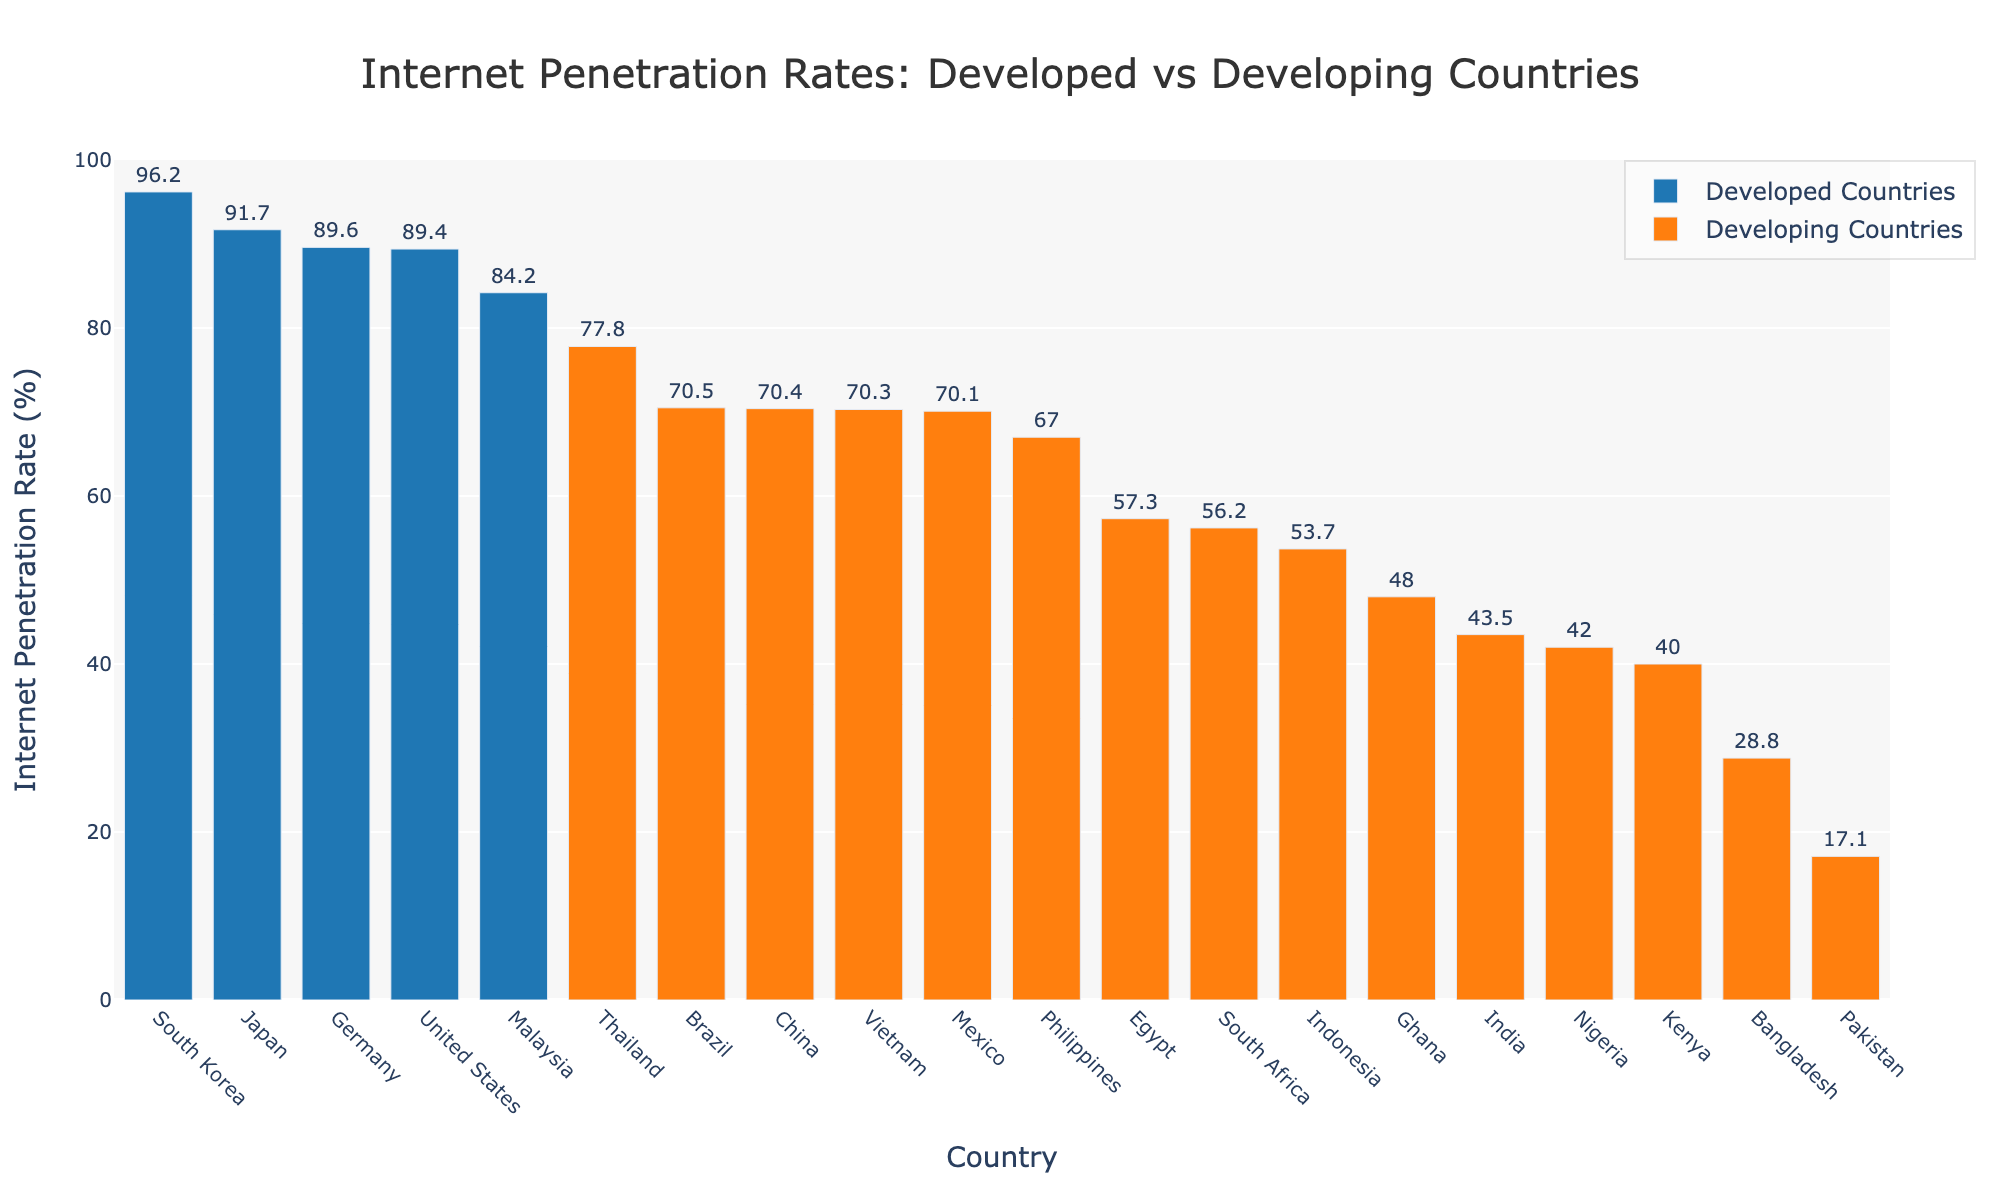Which country has the highest Internet penetration rate among developing countries? To find the country with the highest Internet penetration rate among developing countries, look for the tallest orange bar in the figure, representing developing countries. Compare the heights of the bars to identify the highest one.
Answer: South Korea What is the Internet penetration rate difference between Japan and India? Identify the bars representing Japan and India, then note their Internet penetration rates. Subtract India's rate (43.5%) from Japan's rate (91.7%) to get the difference.
Answer: 48.2% Which group, developed or developing countries, has the country with the lowest Internet penetration rate? Look for the shortest bar in the entire figure. Since the shortest one will indicate the lowest Internet penetration rate, determine if this bar belongs to a developed or developing country by its color (blue for developed, orange for developing).
Answer: Developing countries What is the total Internet penetration rate of the United States and Germany? Identify the bars for the United States and Germany, note their Internet penetration rates (89.4% and 89.6% respectively), and add these two values together.
Answer: 179.0% Among the group of developing countries, which country has an Internet penetration rate closest to 50%? Examine the orange bars representing developing countries and find the one nearest to the 50% mark. Compare the exact rates listed above each bar to determine which is closest to 50%.
Answer: Ghana How much higher is South Korea's Internet penetration rate compared to China's? Locate the bars for South Korea and China and note their Internet penetration rates (96.2% and 70.4%, respectively). Subtract China's rate from South Korea's to find the difference.
Answer: 25.8% Which countries fall into the group with Internet penetration rates between 40% and 60%? Identify bars whose heights range between the 40% and 60% marks on the y-axis. Note the countries these bars represent.
Answer: Nigeria, Indonesia, Kenya, Egypt, South Africa What is the average Internet penetration rate of the five developed countries in the figure? Note the Internet penetration rates for the five developed countries (United States, Germany, Japan, South Korea, Malaysia: 89.4%, 89.6%, 91.7%, 96.2%, 84.2%), add them up, and divide by five to get the average.
Answer: 90.2% How does Thailand's Internet penetration rate compare to that of the Philippines? Identify the bars for Thailand and the Philippines, note their Internet penetration rates (77.8% and 67.0% respectively), and compare the heights. Thailand's rate is higher.
Answer: Thailand’s rate is higher Which country has a higher Internet penetration rate: Brazil or Mexico? Locate the bars for Brazil and Mexico, note their Internet penetration rates (70.5% and 70.1% respectively), and compare them.
Answer: Brazil 